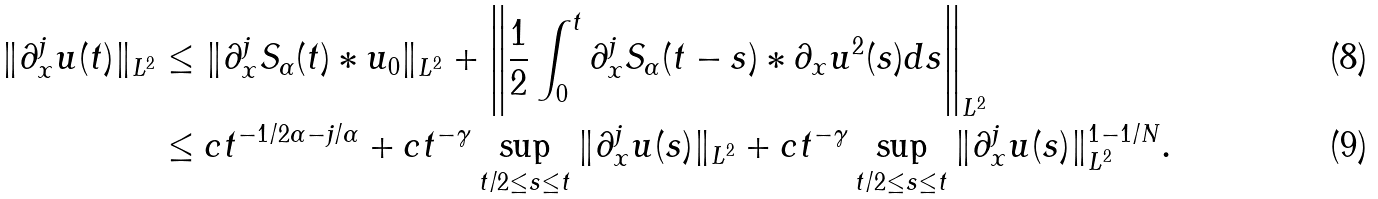<formula> <loc_0><loc_0><loc_500><loc_500>\| \partial _ { x } ^ { j } u ( t ) \| _ { L ^ { 2 } } & \leq \| \partial _ { x } ^ { j } S _ { \alpha } ( t ) \ast u _ { 0 } \| _ { L ^ { 2 } } + \left \| \frac { 1 } { 2 } \int _ { 0 } ^ { t } \partial _ { x } ^ { j } S _ { \alpha } ( t - s ) \ast \partial _ { x } u ^ { 2 } ( s ) d s \right \| _ { L ^ { 2 } } \\ & \leq c t ^ { - 1 / 2 \alpha - j / \alpha } + c t ^ { - \gamma } \sup _ { t / 2 \leq s \leq t } \| \partial _ { x } ^ { j } u ( s ) \| _ { L ^ { 2 } } + c t ^ { - \gamma } \sup _ { t / 2 \leq s \leq t } \| \partial _ { x } ^ { j } u ( s ) \| _ { L ^ { 2 } } ^ { 1 - 1 / N } .</formula> 